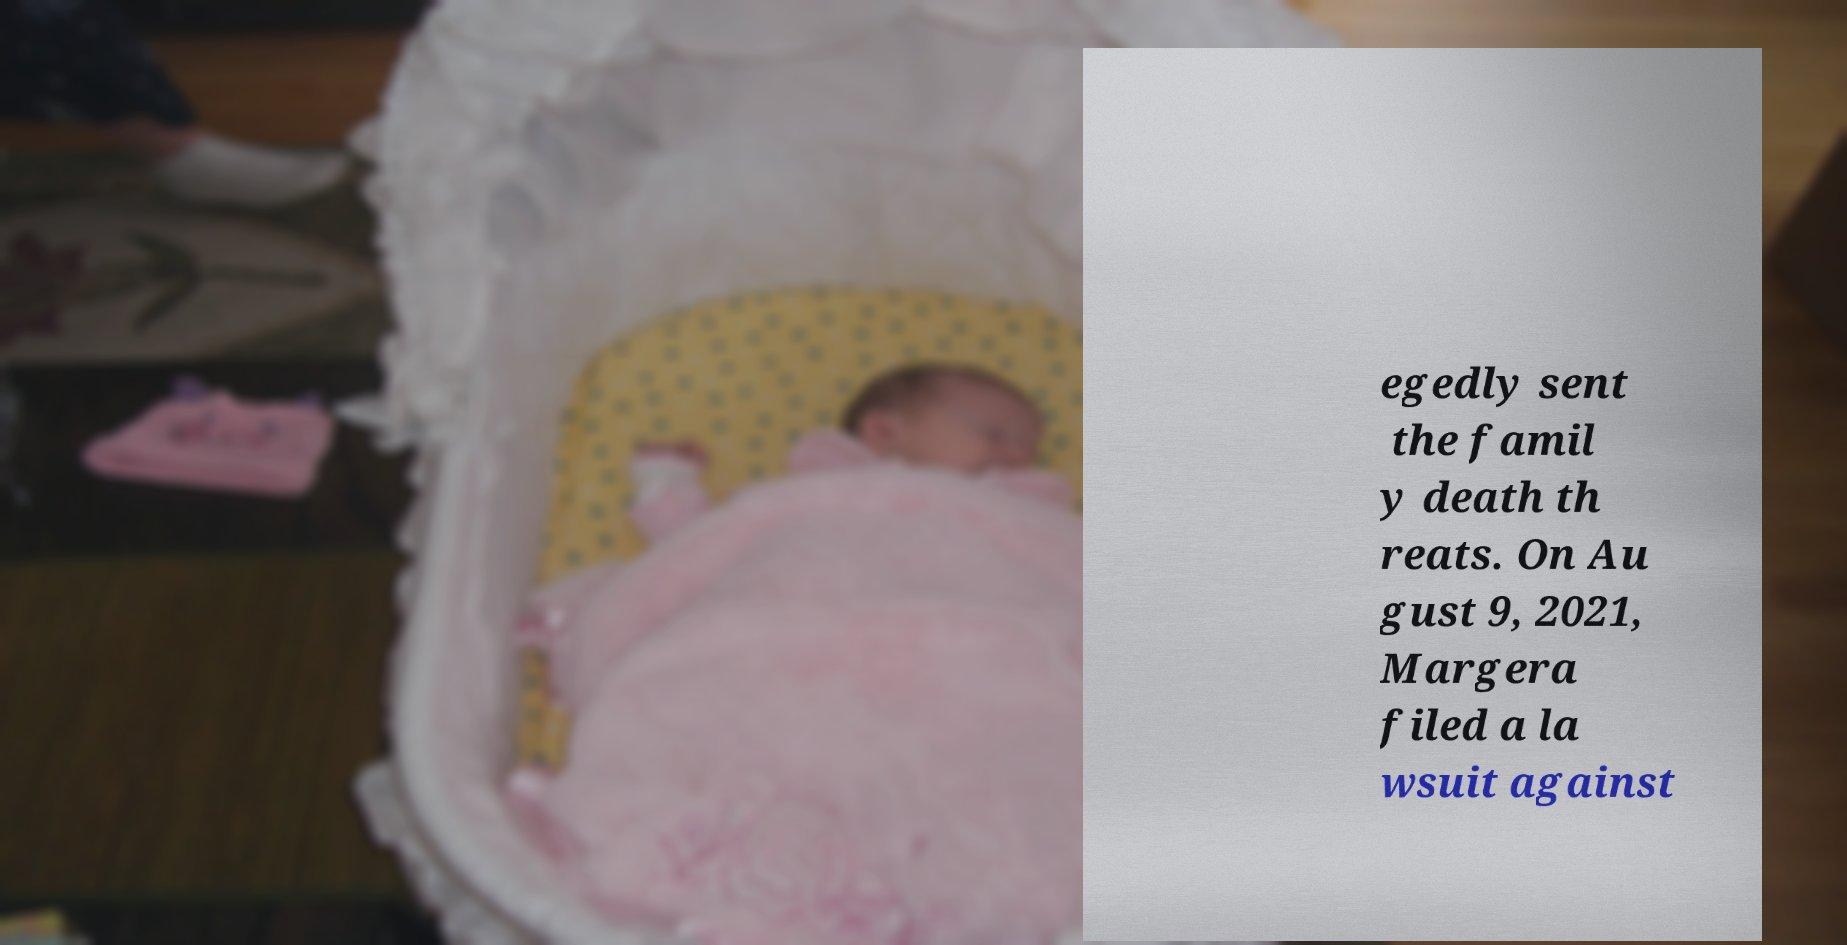Can you accurately transcribe the text from the provided image for me? egedly sent the famil y death th reats. On Au gust 9, 2021, Margera filed a la wsuit against 